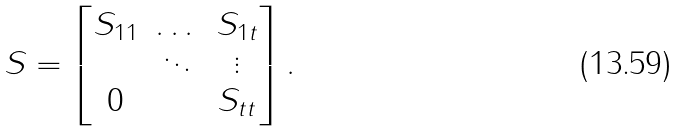Convert formula to latex. <formula><loc_0><loc_0><loc_500><loc_500>S = \begin{bmatrix} S _ { 1 1 } & \dots & S _ { 1 t } \\ & \ddots & \vdots \\ 0 & & S _ { t t } \end{bmatrix} .</formula> 